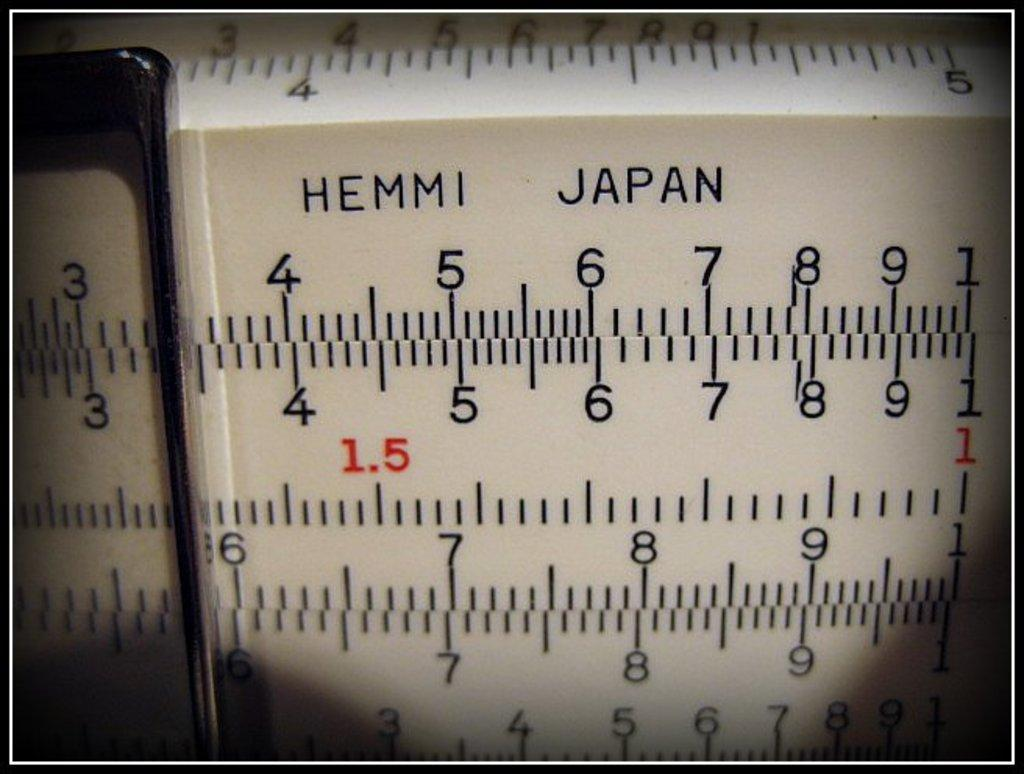<image>
Render a clear and concise summary of the photo. A measuring system that reads hemmi japan in the top of the measures. 